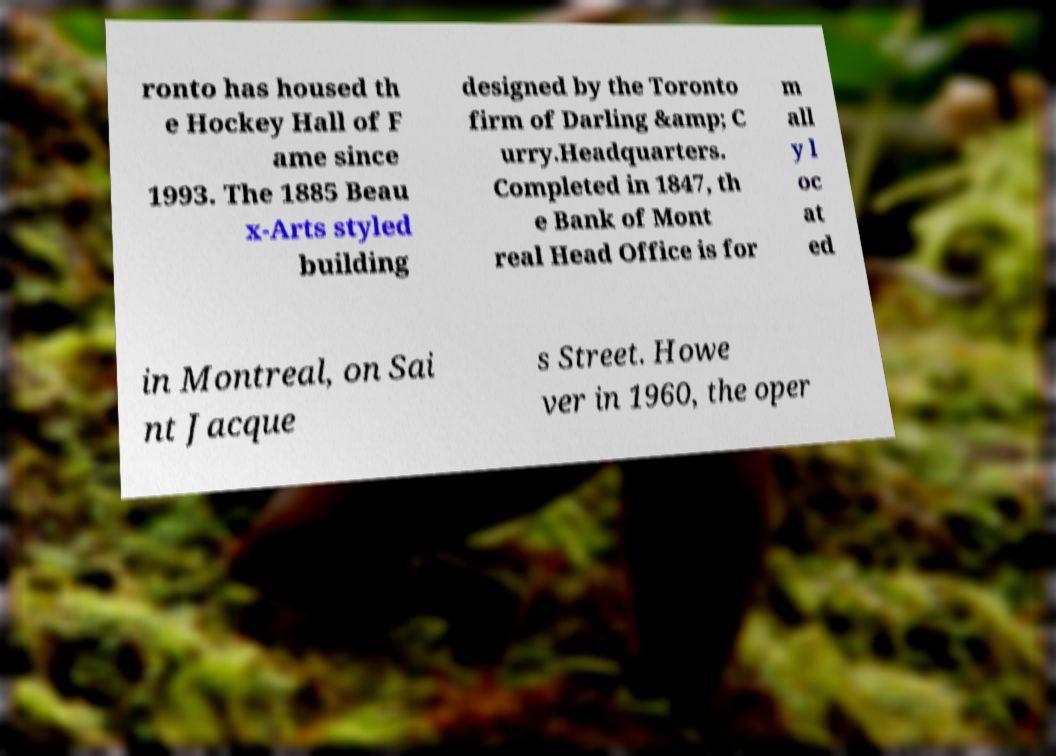Could you assist in decoding the text presented in this image and type it out clearly? ronto has housed th e Hockey Hall of F ame since 1993. The 1885 Beau x-Arts styled building designed by the Toronto firm of Darling &amp; C urry.Headquarters. Completed in 1847, th e Bank of Mont real Head Office is for m all y l oc at ed in Montreal, on Sai nt Jacque s Street. Howe ver in 1960, the oper 